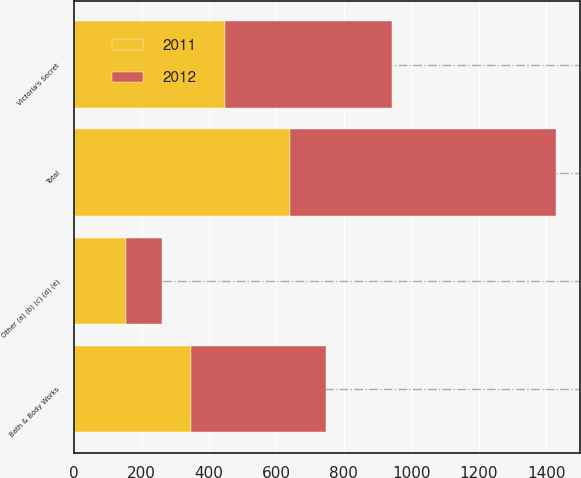Convert chart to OTSL. <chart><loc_0><loc_0><loc_500><loc_500><stacked_bar_chart><ecel><fcel>Victoria's Secret<fcel>Bath & Body Works<fcel>Other (a) (b) (c) (d) (e)<fcel>Total<nl><fcel>2012<fcel>496<fcel>398<fcel>106<fcel>788<nl><fcel>2011<fcel>447<fcel>348<fcel>154<fcel>641<nl></chart> 